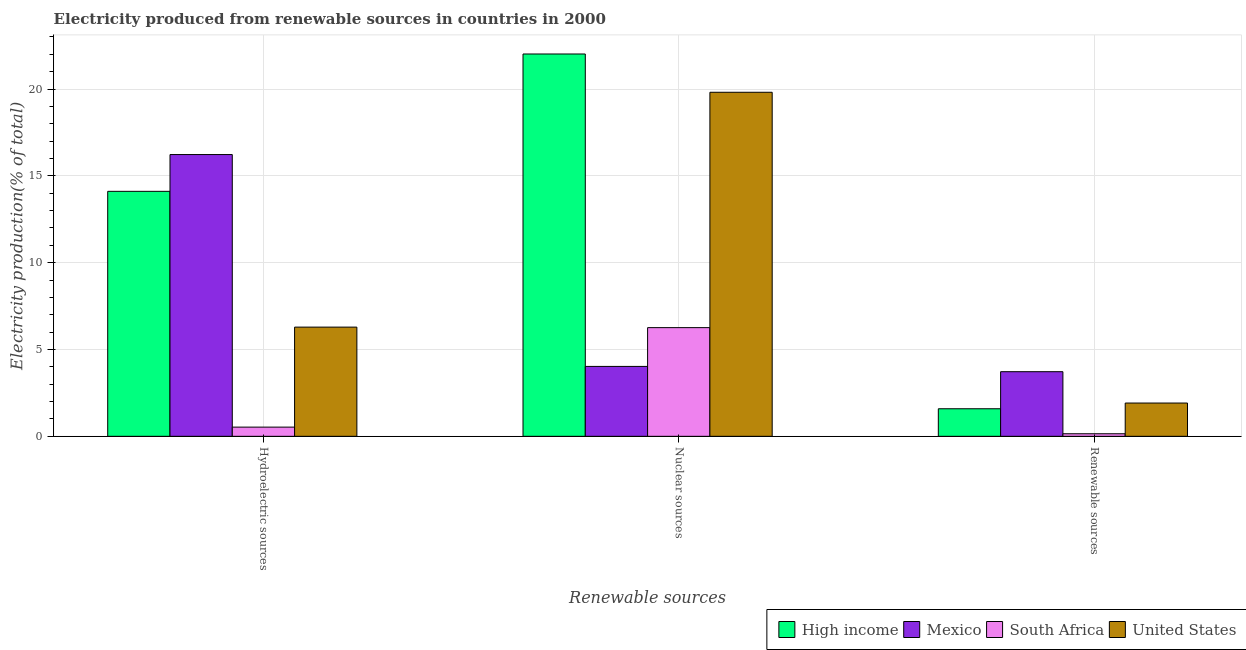How many different coloured bars are there?
Keep it short and to the point. 4. How many groups of bars are there?
Give a very brief answer. 3. Are the number of bars per tick equal to the number of legend labels?
Keep it short and to the point. Yes. Are the number of bars on each tick of the X-axis equal?
Your answer should be very brief. Yes. What is the label of the 1st group of bars from the left?
Make the answer very short. Hydroelectric sources. What is the percentage of electricity produced by hydroelectric sources in High income?
Offer a very short reply. 14.11. Across all countries, what is the maximum percentage of electricity produced by nuclear sources?
Offer a terse response. 22.02. Across all countries, what is the minimum percentage of electricity produced by hydroelectric sources?
Provide a short and direct response. 0.53. What is the total percentage of electricity produced by nuclear sources in the graph?
Your answer should be very brief. 52.12. What is the difference between the percentage of electricity produced by nuclear sources in High income and that in United States?
Your answer should be compact. 2.21. What is the difference between the percentage of electricity produced by nuclear sources in United States and the percentage of electricity produced by renewable sources in Mexico?
Offer a very short reply. 16.09. What is the average percentage of electricity produced by renewable sources per country?
Offer a terse response. 1.84. What is the difference between the percentage of electricity produced by renewable sources and percentage of electricity produced by nuclear sources in Mexico?
Provide a succinct answer. -0.3. What is the ratio of the percentage of electricity produced by hydroelectric sources in High income to that in Mexico?
Offer a very short reply. 0.87. Is the percentage of electricity produced by nuclear sources in South Africa less than that in High income?
Keep it short and to the point. Yes. Is the difference between the percentage of electricity produced by renewable sources in South Africa and High income greater than the difference between the percentage of electricity produced by nuclear sources in South Africa and High income?
Your answer should be compact. Yes. What is the difference between the highest and the second highest percentage of electricity produced by renewable sources?
Make the answer very short. 1.81. What is the difference between the highest and the lowest percentage of electricity produced by renewable sources?
Your answer should be very brief. 3.57. In how many countries, is the percentage of electricity produced by hydroelectric sources greater than the average percentage of electricity produced by hydroelectric sources taken over all countries?
Give a very brief answer. 2. How many bars are there?
Provide a succinct answer. 12. Are all the bars in the graph horizontal?
Give a very brief answer. No. What is the difference between two consecutive major ticks on the Y-axis?
Ensure brevity in your answer.  5. Are the values on the major ticks of Y-axis written in scientific E-notation?
Ensure brevity in your answer.  No. Does the graph contain grids?
Offer a terse response. Yes. How many legend labels are there?
Ensure brevity in your answer.  4. What is the title of the graph?
Keep it short and to the point. Electricity produced from renewable sources in countries in 2000. Does "Gambia, The" appear as one of the legend labels in the graph?
Make the answer very short. No. What is the label or title of the X-axis?
Make the answer very short. Renewable sources. What is the Electricity production(% of total) in High income in Hydroelectric sources?
Give a very brief answer. 14.11. What is the Electricity production(% of total) of Mexico in Hydroelectric sources?
Your answer should be compact. 16.23. What is the Electricity production(% of total) in South Africa in Hydroelectric sources?
Provide a succinct answer. 0.53. What is the Electricity production(% of total) of United States in Hydroelectric sources?
Ensure brevity in your answer.  6.29. What is the Electricity production(% of total) of High income in Nuclear sources?
Your answer should be very brief. 22.02. What is the Electricity production(% of total) in Mexico in Nuclear sources?
Ensure brevity in your answer.  4.03. What is the Electricity production(% of total) of South Africa in Nuclear sources?
Make the answer very short. 6.26. What is the Electricity production(% of total) in United States in Nuclear sources?
Your response must be concise. 19.81. What is the Electricity production(% of total) in High income in Renewable sources?
Provide a short and direct response. 1.59. What is the Electricity production(% of total) of Mexico in Renewable sources?
Offer a very short reply. 3.72. What is the Electricity production(% of total) of South Africa in Renewable sources?
Ensure brevity in your answer.  0.15. What is the Electricity production(% of total) of United States in Renewable sources?
Your answer should be compact. 1.92. Across all Renewable sources, what is the maximum Electricity production(% of total) of High income?
Your response must be concise. 22.02. Across all Renewable sources, what is the maximum Electricity production(% of total) in Mexico?
Make the answer very short. 16.23. Across all Renewable sources, what is the maximum Electricity production(% of total) of South Africa?
Make the answer very short. 6.26. Across all Renewable sources, what is the maximum Electricity production(% of total) in United States?
Offer a terse response. 19.81. Across all Renewable sources, what is the minimum Electricity production(% of total) of High income?
Ensure brevity in your answer.  1.59. Across all Renewable sources, what is the minimum Electricity production(% of total) in Mexico?
Keep it short and to the point. 3.72. Across all Renewable sources, what is the minimum Electricity production(% of total) in South Africa?
Your answer should be compact. 0.15. Across all Renewable sources, what is the minimum Electricity production(% of total) in United States?
Ensure brevity in your answer.  1.92. What is the total Electricity production(% of total) in High income in the graph?
Offer a terse response. 37.72. What is the total Electricity production(% of total) in Mexico in the graph?
Keep it short and to the point. 23.98. What is the total Electricity production(% of total) in South Africa in the graph?
Give a very brief answer. 6.94. What is the total Electricity production(% of total) of United States in the graph?
Offer a terse response. 28.02. What is the difference between the Electricity production(% of total) of High income in Hydroelectric sources and that in Nuclear sources?
Provide a short and direct response. -7.91. What is the difference between the Electricity production(% of total) in Mexico in Hydroelectric sources and that in Nuclear sources?
Offer a terse response. 12.2. What is the difference between the Electricity production(% of total) in South Africa in Hydroelectric sources and that in Nuclear sources?
Provide a succinct answer. -5.73. What is the difference between the Electricity production(% of total) in United States in Hydroelectric sources and that in Nuclear sources?
Make the answer very short. -13.53. What is the difference between the Electricity production(% of total) of High income in Hydroelectric sources and that in Renewable sources?
Keep it short and to the point. 12.52. What is the difference between the Electricity production(% of total) in Mexico in Hydroelectric sources and that in Renewable sources?
Your answer should be very brief. 12.51. What is the difference between the Electricity production(% of total) of South Africa in Hydroelectric sources and that in Renewable sources?
Your response must be concise. 0.38. What is the difference between the Electricity production(% of total) of United States in Hydroelectric sources and that in Renewable sources?
Ensure brevity in your answer.  4.37. What is the difference between the Electricity production(% of total) of High income in Nuclear sources and that in Renewable sources?
Keep it short and to the point. 20.43. What is the difference between the Electricity production(% of total) of Mexico in Nuclear sources and that in Renewable sources?
Offer a very short reply. 0.3. What is the difference between the Electricity production(% of total) in South Africa in Nuclear sources and that in Renewable sources?
Your answer should be very brief. 6.11. What is the difference between the Electricity production(% of total) of United States in Nuclear sources and that in Renewable sources?
Offer a very short reply. 17.9. What is the difference between the Electricity production(% of total) in High income in Hydroelectric sources and the Electricity production(% of total) in Mexico in Nuclear sources?
Give a very brief answer. 10.08. What is the difference between the Electricity production(% of total) of High income in Hydroelectric sources and the Electricity production(% of total) of South Africa in Nuclear sources?
Offer a very short reply. 7.85. What is the difference between the Electricity production(% of total) of High income in Hydroelectric sources and the Electricity production(% of total) of United States in Nuclear sources?
Keep it short and to the point. -5.71. What is the difference between the Electricity production(% of total) in Mexico in Hydroelectric sources and the Electricity production(% of total) in South Africa in Nuclear sources?
Provide a succinct answer. 9.97. What is the difference between the Electricity production(% of total) of Mexico in Hydroelectric sources and the Electricity production(% of total) of United States in Nuclear sources?
Your response must be concise. -3.59. What is the difference between the Electricity production(% of total) in South Africa in Hydroelectric sources and the Electricity production(% of total) in United States in Nuclear sources?
Your answer should be compact. -19.29. What is the difference between the Electricity production(% of total) in High income in Hydroelectric sources and the Electricity production(% of total) in Mexico in Renewable sources?
Keep it short and to the point. 10.39. What is the difference between the Electricity production(% of total) of High income in Hydroelectric sources and the Electricity production(% of total) of South Africa in Renewable sources?
Your answer should be very brief. 13.96. What is the difference between the Electricity production(% of total) of High income in Hydroelectric sources and the Electricity production(% of total) of United States in Renewable sources?
Your answer should be compact. 12.19. What is the difference between the Electricity production(% of total) in Mexico in Hydroelectric sources and the Electricity production(% of total) in South Africa in Renewable sources?
Make the answer very short. 16.08. What is the difference between the Electricity production(% of total) in Mexico in Hydroelectric sources and the Electricity production(% of total) in United States in Renewable sources?
Offer a very short reply. 14.31. What is the difference between the Electricity production(% of total) in South Africa in Hydroelectric sources and the Electricity production(% of total) in United States in Renewable sources?
Give a very brief answer. -1.39. What is the difference between the Electricity production(% of total) in High income in Nuclear sources and the Electricity production(% of total) in Mexico in Renewable sources?
Make the answer very short. 18.3. What is the difference between the Electricity production(% of total) in High income in Nuclear sources and the Electricity production(% of total) in South Africa in Renewable sources?
Give a very brief answer. 21.87. What is the difference between the Electricity production(% of total) in High income in Nuclear sources and the Electricity production(% of total) in United States in Renewable sources?
Provide a short and direct response. 20.1. What is the difference between the Electricity production(% of total) of Mexico in Nuclear sources and the Electricity production(% of total) of South Africa in Renewable sources?
Offer a very short reply. 3.88. What is the difference between the Electricity production(% of total) in Mexico in Nuclear sources and the Electricity production(% of total) in United States in Renewable sources?
Provide a short and direct response. 2.11. What is the difference between the Electricity production(% of total) of South Africa in Nuclear sources and the Electricity production(% of total) of United States in Renewable sources?
Your response must be concise. 4.34. What is the average Electricity production(% of total) of High income per Renewable sources?
Offer a very short reply. 12.57. What is the average Electricity production(% of total) in Mexico per Renewable sources?
Offer a very short reply. 7.99. What is the average Electricity production(% of total) in South Africa per Renewable sources?
Provide a short and direct response. 2.31. What is the average Electricity production(% of total) of United States per Renewable sources?
Your answer should be very brief. 9.34. What is the difference between the Electricity production(% of total) of High income and Electricity production(% of total) of Mexico in Hydroelectric sources?
Your answer should be compact. -2.12. What is the difference between the Electricity production(% of total) of High income and Electricity production(% of total) of South Africa in Hydroelectric sources?
Your answer should be compact. 13.58. What is the difference between the Electricity production(% of total) of High income and Electricity production(% of total) of United States in Hydroelectric sources?
Give a very brief answer. 7.82. What is the difference between the Electricity production(% of total) in Mexico and Electricity production(% of total) in South Africa in Hydroelectric sources?
Keep it short and to the point. 15.7. What is the difference between the Electricity production(% of total) in Mexico and Electricity production(% of total) in United States in Hydroelectric sources?
Offer a very short reply. 9.94. What is the difference between the Electricity production(% of total) in South Africa and Electricity production(% of total) in United States in Hydroelectric sources?
Your answer should be compact. -5.76. What is the difference between the Electricity production(% of total) of High income and Electricity production(% of total) of Mexico in Nuclear sources?
Keep it short and to the point. 17.99. What is the difference between the Electricity production(% of total) in High income and Electricity production(% of total) in South Africa in Nuclear sources?
Ensure brevity in your answer.  15.76. What is the difference between the Electricity production(% of total) of High income and Electricity production(% of total) of United States in Nuclear sources?
Make the answer very short. 2.21. What is the difference between the Electricity production(% of total) of Mexico and Electricity production(% of total) of South Africa in Nuclear sources?
Your answer should be compact. -2.23. What is the difference between the Electricity production(% of total) in Mexico and Electricity production(% of total) in United States in Nuclear sources?
Your answer should be compact. -15.79. What is the difference between the Electricity production(% of total) in South Africa and Electricity production(% of total) in United States in Nuclear sources?
Offer a very short reply. -13.55. What is the difference between the Electricity production(% of total) of High income and Electricity production(% of total) of Mexico in Renewable sources?
Provide a succinct answer. -2.13. What is the difference between the Electricity production(% of total) in High income and Electricity production(% of total) in South Africa in Renewable sources?
Make the answer very short. 1.44. What is the difference between the Electricity production(% of total) of High income and Electricity production(% of total) of United States in Renewable sources?
Your response must be concise. -0.33. What is the difference between the Electricity production(% of total) in Mexico and Electricity production(% of total) in South Africa in Renewable sources?
Provide a short and direct response. 3.57. What is the difference between the Electricity production(% of total) in Mexico and Electricity production(% of total) in United States in Renewable sources?
Your response must be concise. 1.81. What is the difference between the Electricity production(% of total) of South Africa and Electricity production(% of total) of United States in Renewable sources?
Offer a terse response. -1.77. What is the ratio of the Electricity production(% of total) of High income in Hydroelectric sources to that in Nuclear sources?
Offer a terse response. 0.64. What is the ratio of the Electricity production(% of total) in Mexico in Hydroelectric sources to that in Nuclear sources?
Provide a succinct answer. 4.03. What is the ratio of the Electricity production(% of total) in South Africa in Hydroelectric sources to that in Nuclear sources?
Your response must be concise. 0.08. What is the ratio of the Electricity production(% of total) in United States in Hydroelectric sources to that in Nuclear sources?
Provide a succinct answer. 0.32. What is the ratio of the Electricity production(% of total) of High income in Hydroelectric sources to that in Renewable sources?
Provide a short and direct response. 8.89. What is the ratio of the Electricity production(% of total) in Mexico in Hydroelectric sources to that in Renewable sources?
Offer a very short reply. 4.36. What is the ratio of the Electricity production(% of total) of South Africa in Hydroelectric sources to that in Renewable sources?
Provide a succinct answer. 3.59. What is the ratio of the Electricity production(% of total) of United States in Hydroelectric sources to that in Renewable sources?
Provide a short and direct response. 3.28. What is the ratio of the Electricity production(% of total) in High income in Nuclear sources to that in Renewable sources?
Offer a terse response. 13.88. What is the ratio of the Electricity production(% of total) in Mexico in Nuclear sources to that in Renewable sources?
Provide a succinct answer. 1.08. What is the ratio of the Electricity production(% of total) in South Africa in Nuclear sources to that in Renewable sources?
Give a very brief answer. 42.38. What is the ratio of the Electricity production(% of total) in United States in Nuclear sources to that in Renewable sources?
Make the answer very short. 10.34. What is the difference between the highest and the second highest Electricity production(% of total) of High income?
Keep it short and to the point. 7.91. What is the difference between the highest and the second highest Electricity production(% of total) in Mexico?
Keep it short and to the point. 12.2. What is the difference between the highest and the second highest Electricity production(% of total) of South Africa?
Your response must be concise. 5.73. What is the difference between the highest and the second highest Electricity production(% of total) in United States?
Provide a short and direct response. 13.53. What is the difference between the highest and the lowest Electricity production(% of total) of High income?
Ensure brevity in your answer.  20.43. What is the difference between the highest and the lowest Electricity production(% of total) in Mexico?
Provide a short and direct response. 12.51. What is the difference between the highest and the lowest Electricity production(% of total) in South Africa?
Make the answer very short. 6.11. What is the difference between the highest and the lowest Electricity production(% of total) in United States?
Your answer should be very brief. 17.9. 